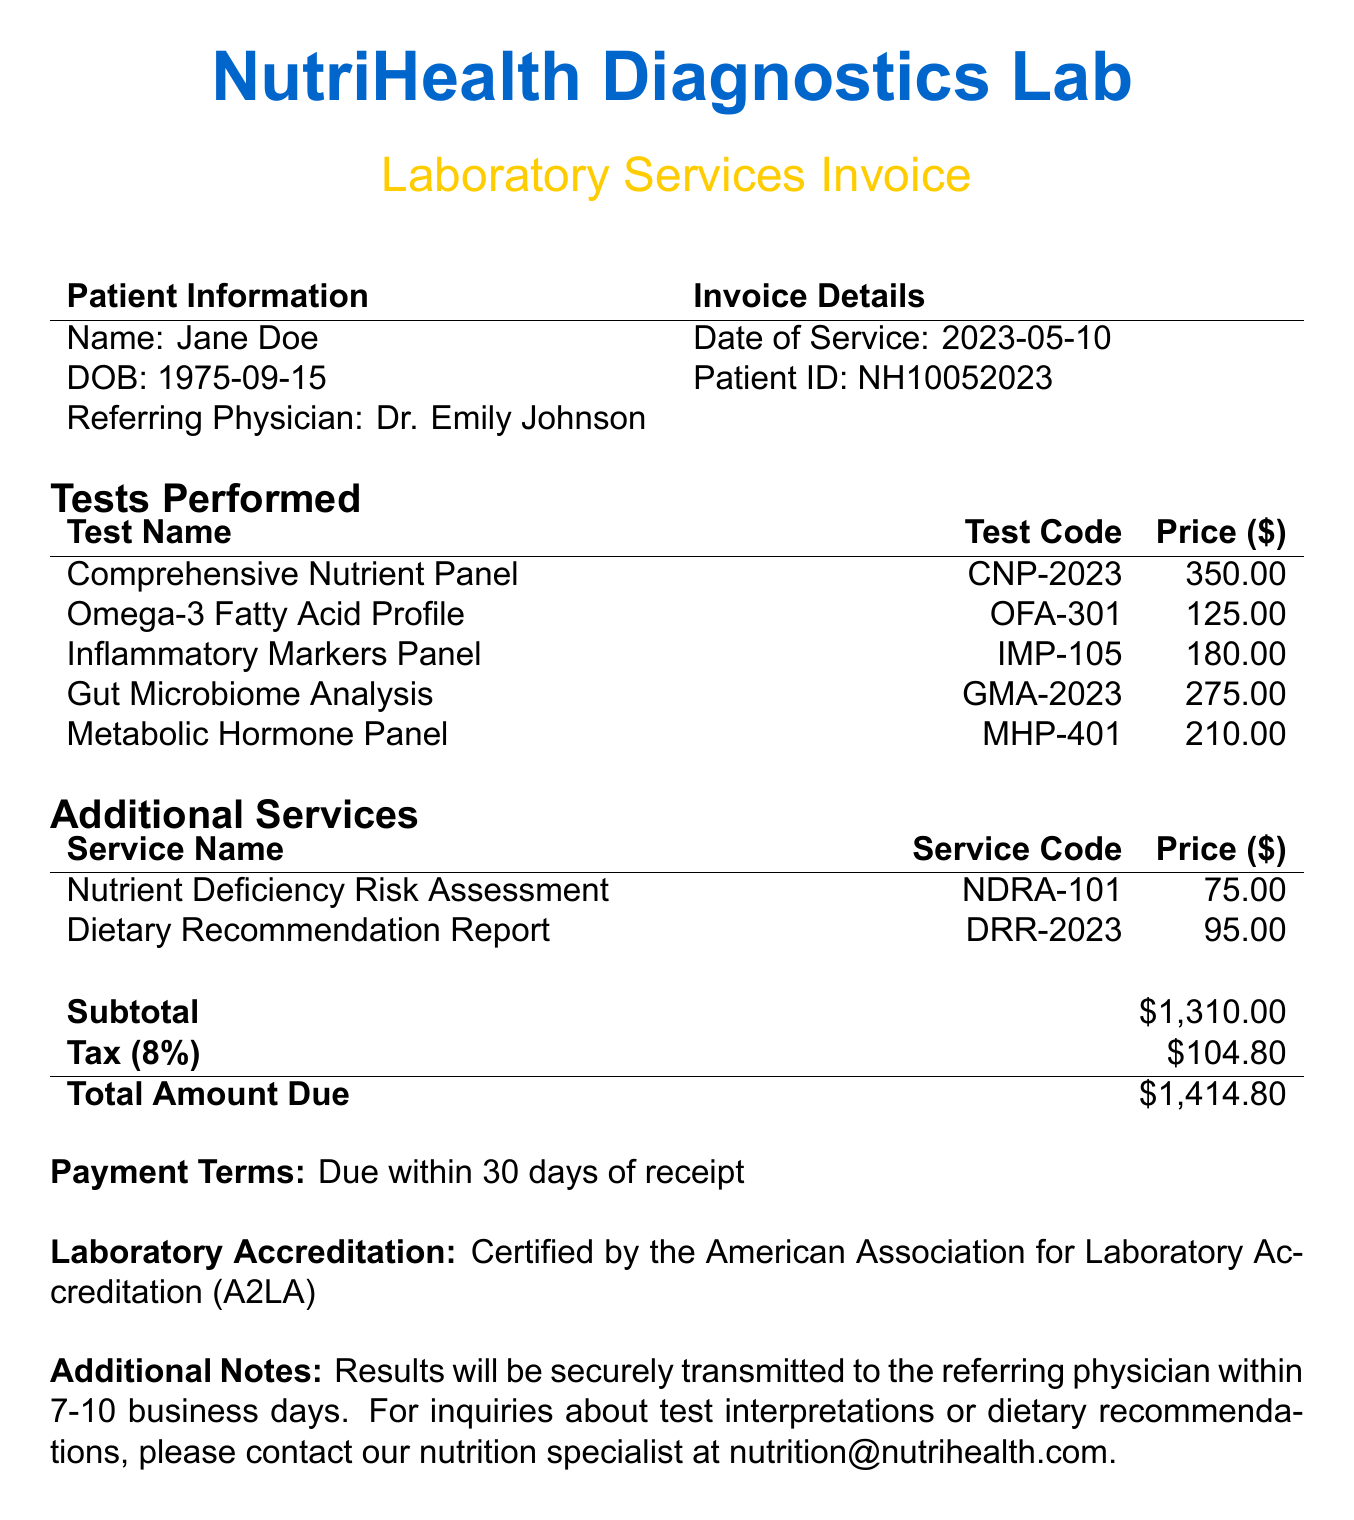What is the name of the laboratory? The name of the laboratory is mentioned at the top of the document.
Answer: NutriHealth Diagnostics Lab What is the date of service? The date of service is specified in the invoice details section.
Answer: 2023-05-10 How many tests were performed? The number of tests can be counted from the "Tests Performed" section.
Answer: 5 What is the total amount due? The total amount due is calculated in the billing details section.
Answer: $1,414.80 What test code corresponds to the Omega-3 Fatty Acid Profile? The test code is listed next to the name of the test in the "Tests Performed" section.
Answer: OFA-301 What additional service is related to nutrient deficiency? The "Additional Services" section lists services, one of which relates to nutrient deficiency.
Answer: Nutrient Deficiency Risk Assessment What is the tax rate applied to the invoice? The tax rate is specified in the billing details section.
Answer: 8% Who is the referring physician? The referring physician's name is mentioned in the patient information section.
Answer: Dr. Emily Johnson What is the price of the Gut Microbiome Analysis test? The price is listed in the table under "Tests Performed."
Answer: 275.00 